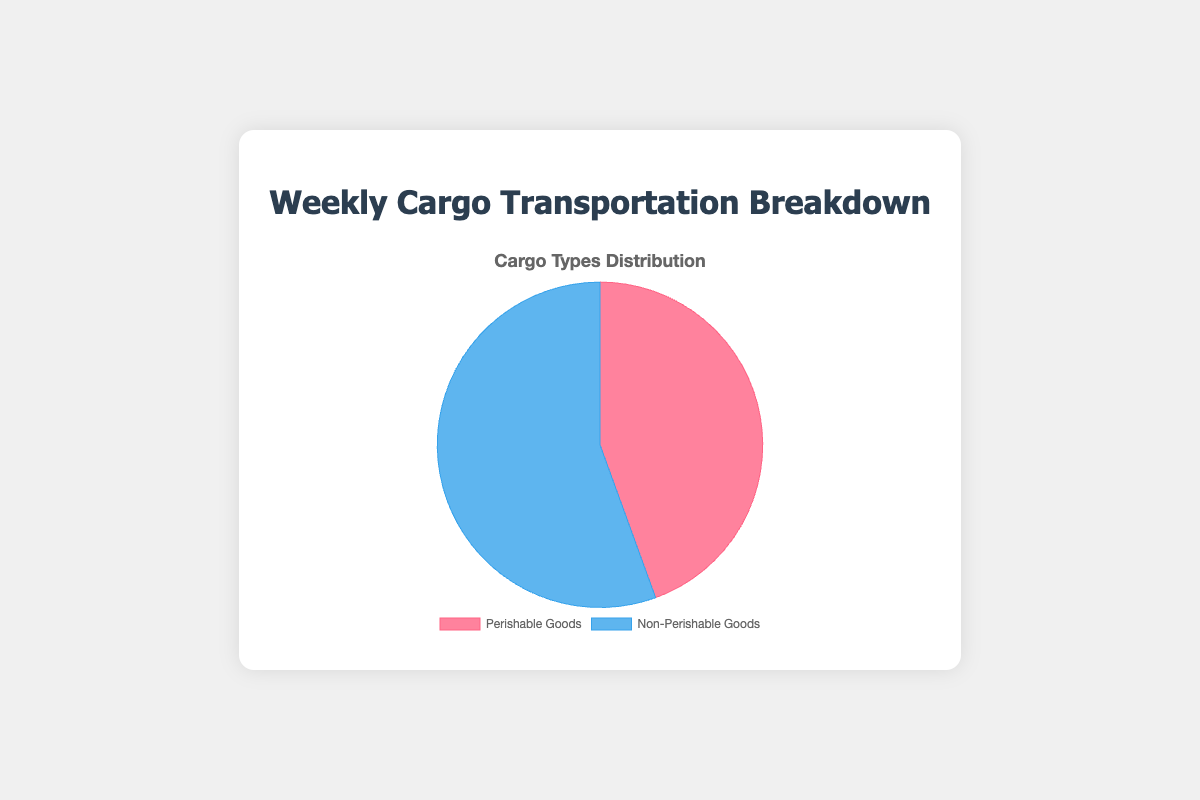What types of goods are represented by the two colors in the pie chart? The two colors in the pie chart represent 'Perishable Goods' and 'Non-Perishable Goods'. The pie chart likely uses distinct colors like red for 'Perishable Goods' and blue for 'Non-Perishable Goods'.
Answer: Perishable and Non-Perishable Goods Which category has a larger share of the pie chart, Perishable or Non-Perishable goods? The chart divides the total cargo into two categories, and the size of each pie slice represents the total loads for each category. Non-Perishable goods have a larger slice than Perishable goods.
Answer: Non-Perishable Goods What percentage of the total cargo is Perishable goods? To find the percentage, use the value for Perishable goods (40) and divide it by the total cargo loads, which is the sum of Perishable and Non-Perishable goods (40 + 50 = 90). Then, multiply by 100: (40/90)*100.
Answer: 44.4% How many more loads of Non-Perishable goods are there compared to Perishable goods? Compare the total loads for each category: Non-Perishable goods (50) minus Perishable goods (40).
Answer: 10 loads What is the visual representation of the difference between Perishable and Non-Perishable goods? The pie chart will show a larger slice for Non-Perishable goods than for Perishable goods. The visual difference in the size of the slices represents the difference in the total cargo loads.
Answer: Larger slice for Non-Perishable If 5 additional loads of Dairy Products are added, what will be the new total for Perishable goods? The current total for Perishable goods is 40. Adding 5 loads of Dairy Products will give a new total of 40 + 5.
Answer: 45 loads What is the ratio of Perishable to Non-Perishable goods? The ratio is the total loads of Perishable goods (40) to the total loads of Non-Perishable goods (50). This can be simplified: 40/50 = 4/5 or 0.8.
Answer: 4:5 or 0.8 How much will the percentage of Non-Perishable goods decrease if 5 loads are moved to Perishable goods? Initially, Non-Perishable goods are 50 loads and Perishable goods are 40 loads. Moving 5 loads, Non-Perishable becomes 45 and Perishable becomes 45. New percentage of Non-Perishable = (45/90)*100. The initial percentage was (50/90)*100. Calculate the decrease. Decrease = Initial - new = (50/90*100) - (45/90*100).
Answer: Decrease of 5.6% What type of good (Perishable or Non-Perishable) forms the smallest part of the pie chart? The chart shows Perishable and Non-Perishable categories. The smaller slice in the pie chart represents the category with fewer loads.
Answer: Perishable Goods 